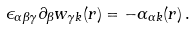Convert formula to latex. <formula><loc_0><loc_0><loc_500><loc_500>\epsilon _ { \alpha \beta \gamma } \partial _ { \beta } w _ { \gamma k } ( { r } ) = - \alpha _ { \alpha k } ( { r } ) \, .</formula> 